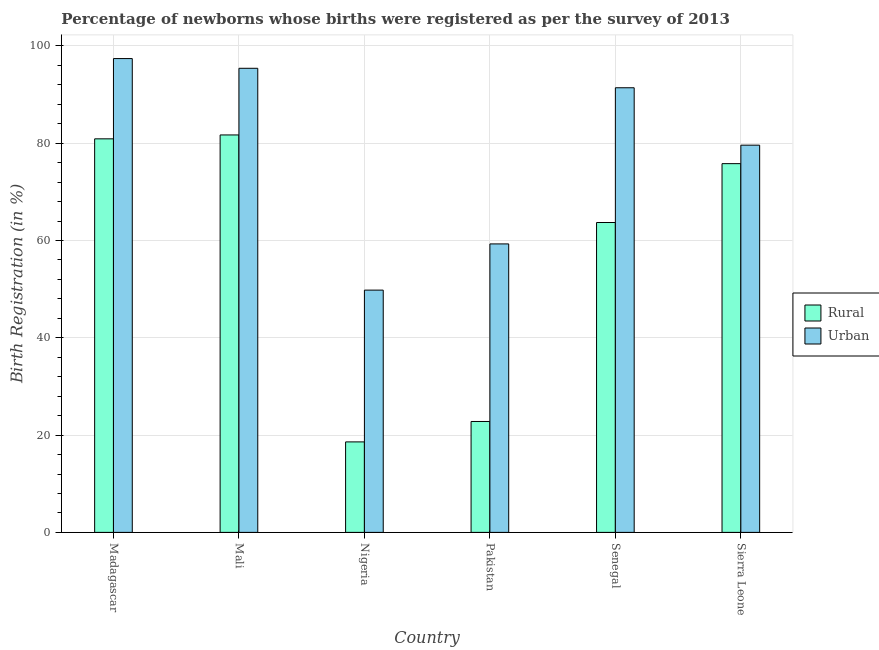How many groups of bars are there?
Your response must be concise. 6. Are the number of bars on each tick of the X-axis equal?
Your answer should be compact. Yes. How many bars are there on the 6th tick from the right?
Offer a terse response. 2. What is the label of the 6th group of bars from the left?
Provide a short and direct response. Sierra Leone. Across all countries, what is the maximum urban birth registration?
Your answer should be very brief. 97.4. Across all countries, what is the minimum rural birth registration?
Provide a short and direct response. 18.6. In which country was the rural birth registration maximum?
Make the answer very short. Mali. In which country was the rural birth registration minimum?
Your answer should be very brief. Nigeria. What is the total urban birth registration in the graph?
Your response must be concise. 472.9. What is the difference between the urban birth registration in Madagascar and that in Sierra Leone?
Offer a very short reply. 17.8. What is the average urban birth registration per country?
Provide a succinct answer. 78.82. What is the ratio of the urban birth registration in Senegal to that in Sierra Leone?
Your response must be concise. 1.15. What is the difference between the highest and the second highest rural birth registration?
Your response must be concise. 0.8. What is the difference between the highest and the lowest rural birth registration?
Make the answer very short. 63.1. Is the sum of the rural birth registration in Pakistan and Senegal greater than the maximum urban birth registration across all countries?
Your answer should be very brief. No. What does the 2nd bar from the left in Pakistan represents?
Offer a terse response. Urban. What does the 2nd bar from the right in Sierra Leone represents?
Provide a short and direct response. Rural. How many bars are there?
Your answer should be very brief. 12. Are the values on the major ticks of Y-axis written in scientific E-notation?
Offer a very short reply. No. Where does the legend appear in the graph?
Give a very brief answer. Center right. How many legend labels are there?
Keep it short and to the point. 2. What is the title of the graph?
Offer a terse response. Percentage of newborns whose births were registered as per the survey of 2013. Does "Gasoline" appear as one of the legend labels in the graph?
Make the answer very short. No. What is the label or title of the X-axis?
Offer a very short reply. Country. What is the label or title of the Y-axis?
Give a very brief answer. Birth Registration (in %). What is the Birth Registration (in %) in Rural in Madagascar?
Keep it short and to the point. 80.9. What is the Birth Registration (in %) in Urban in Madagascar?
Your response must be concise. 97.4. What is the Birth Registration (in %) in Rural in Mali?
Make the answer very short. 81.7. What is the Birth Registration (in %) in Urban in Mali?
Your answer should be compact. 95.4. What is the Birth Registration (in %) of Urban in Nigeria?
Your answer should be very brief. 49.8. What is the Birth Registration (in %) of Rural in Pakistan?
Your answer should be compact. 22.8. What is the Birth Registration (in %) in Urban in Pakistan?
Provide a short and direct response. 59.3. What is the Birth Registration (in %) in Rural in Senegal?
Ensure brevity in your answer.  63.7. What is the Birth Registration (in %) of Urban in Senegal?
Offer a very short reply. 91.4. What is the Birth Registration (in %) of Rural in Sierra Leone?
Your answer should be compact. 75.8. What is the Birth Registration (in %) of Urban in Sierra Leone?
Keep it short and to the point. 79.6. Across all countries, what is the maximum Birth Registration (in %) of Rural?
Give a very brief answer. 81.7. Across all countries, what is the maximum Birth Registration (in %) of Urban?
Provide a succinct answer. 97.4. Across all countries, what is the minimum Birth Registration (in %) of Urban?
Give a very brief answer. 49.8. What is the total Birth Registration (in %) in Rural in the graph?
Your answer should be compact. 343.5. What is the total Birth Registration (in %) in Urban in the graph?
Make the answer very short. 472.9. What is the difference between the Birth Registration (in %) in Urban in Madagascar and that in Mali?
Offer a very short reply. 2. What is the difference between the Birth Registration (in %) in Rural in Madagascar and that in Nigeria?
Your answer should be compact. 62.3. What is the difference between the Birth Registration (in %) in Urban in Madagascar and that in Nigeria?
Your answer should be very brief. 47.6. What is the difference between the Birth Registration (in %) in Rural in Madagascar and that in Pakistan?
Give a very brief answer. 58.1. What is the difference between the Birth Registration (in %) in Urban in Madagascar and that in Pakistan?
Your answer should be compact. 38.1. What is the difference between the Birth Registration (in %) of Rural in Madagascar and that in Senegal?
Provide a succinct answer. 17.2. What is the difference between the Birth Registration (in %) of Rural in Mali and that in Nigeria?
Make the answer very short. 63.1. What is the difference between the Birth Registration (in %) of Urban in Mali and that in Nigeria?
Your response must be concise. 45.6. What is the difference between the Birth Registration (in %) of Rural in Mali and that in Pakistan?
Keep it short and to the point. 58.9. What is the difference between the Birth Registration (in %) in Urban in Mali and that in Pakistan?
Provide a succinct answer. 36.1. What is the difference between the Birth Registration (in %) in Urban in Mali and that in Sierra Leone?
Offer a terse response. 15.8. What is the difference between the Birth Registration (in %) of Rural in Nigeria and that in Pakistan?
Make the answer very short. -4.2. What is the difference between the Birth Registration (in %) of Rural in Nigeria and that in Senegal?
Provide a succinct answer. -45.1. What is the difference between the Birth Registration (in %) in Urban in Nigeria and that in Senegal?
Make the answer very short. -41.6. What is the difference between the Birth Registration (in %) of Rural in Nigeria and that in Sierra Leone?
Your response must be concise. -57.2. What is the difference between the Birth Registration (in %) in Urban in Nigeria and that in Sierra Leone?
Your answer should be very brief. -29.8. What is the difference between the Birth Registration (in %) of Rural in Pakistan and that in Senegal?
Provide a succinct answer. -40.9. What is the difference between the Birth Registration (in %) of Urban in Pakistan and that in Senegal?
Your answer should be compact. -32.1. What is the difference between the Birth Registration (in %) in Rural in Pakistan and that in Sierra Leone?
Your response must be concise. -53. What is the difference between the Birth Registration (in %) in Urban in Pakistan and that in Sierra Leone?
Keep it short and to the point. -20.3. What is the difference between the Birth Registration (in %) of Rural in Madagascar and the Birth Registration (in %) of Urban in Nigeria?
Offer a very short reply. 31.1. What is the difference between the Birth Registration (in %) in Rural in Madagascar and the Birth Registration (in %) in Urban in Pakistan?
Your answer should be compact. 21.6. What is the difference between the Birth Registration (in %) of Rural in Mali and the Birth Registration (in %) of Urban in Nigeria?
Provide a succinct answer. 31.9. What is the difference between the Birth Registration (in %) of Rural in Mali and the Birth Registration (in %) of Urban in Pakistan?
Give a very brief answer. 22.4. What is the difference between the Birth Registration (in %) of Rural in Mali and the Birth Registration (in %) of Urban in Senegal?
Provide a succinct answer. -9.7. What is the difference between the Birth Registration (in %) of Rural in Nigeria and the Birth Registration (in %) of Urban in Pakistan?
Provide a short and direct response. -40.7. What is the difference between the Birth Registration (in %) in Rural in Nigeria and the Birth Registration (in %) in Urban in Senegal?
Your response must be concise. -72.8. What is the difference between the Birth Registration (in %) in Rural in Nigeria and the Birth Registration (in %) in Urban in Sierra Leone?
Ensure brevity in your answer.  -61. What is the difference between the Birth Registration (in %) of Rural in Pakistan and the Birth Registration (in %) of Urban in Senegal?
Ensure brevity in your answer.  -68.6. What is the difference between the Birth Registration (in %) of Rural in Pakistan and the Birth Registration (in %) of Urban in Sierra Leone?
Your answer should be compact. -56.8. What is the difference between the Birth Registration (in %) in Rural in Senegal and the Birth Registration (in %) in Urban in Sierra Leone?
Keep it short and to the point. -15.9. What is the average Birth Registration (in %) in Rural per country?
Your answer should be very brief. 57.25. What is the average Birth Registration (in %) of Urban per country?
Make the answer very short. 78.82. What is the difference between the Birth Registration (in %) in Rural and Birth Registration (in %) in Urban in Madagascar?
Make the answer very short. -16.5. What is the difference between the Birth Registration (in %) of Rural and Birth Registration (in %) of Urban in Mali?
Your response must be concise. -13.7. What is the difference between the Birth Registration (in %) in Rural and Birth Registration (in %) in Urban in Nigeria?
Your answer should be very brief. -31.2. What is the difference between the Birth Registration (in %) of Rural and Birth Registration (in %) of Urban in Pakistan?
Your answer should be compact. -36.5. What is the difference between the Birth Registration (in %) of Rural and Birth Registration (in %) of Urban in Senegal?
Offer a terse response. -27.7. What is the difference between the Birth Registration (in %) of Rural and Birth Registration (in %) of Urban in Sierra Leone?
Keep it short and to the point. -3.8. What is the ratio of the Birth Registration (in %) in Rural in Madagascar to that in Mali?
Your answer should be compact. 0.99. What is the ratio of the Birth Registration (in %) of Rural in Madagascar to that in Nigeria?
Your answer should be very brief. 4.35. What is the ratio of the Birth Registration (in %) of Urban in Madagascar to that in Nigeria?
Your response must be concise. 1.96. What is the ratio of the Birth Registration (in %) of Rural in Madagascar to that in Pakistan?
Provide a short and direct response. 3.55. What is the ratio of the Birth Registration (in %) of Urban in Madagascar to that in Pakistan?
Provide a short and direct response. 1.64. What is the ratio of the Birth Registration (in %) in Rural in Madagascar to that in Senegal?
Your answer should be compact. 1.27. What is the ratio of the Birth Registration (in %) in Urban in Madagascar to that in Senegal?
Offer a very short reply. 1.07. What is the ratio of the Birth Registration (in %) of Rural in Madagascar to that in Sierra Leone?
Your answer should be very brief. 1.07. What is the ratio of the Birth Registration (in %) in Urban in Madagascar to that in Sierra Leone?
Make the answer very short. 1.22. What is the ratio of the Birth Registration (in %) in Rural in Mali to that in Nigeria?
Offer a terse response. 4.39. What is the ratio of the Birth Registration (in %) of Urban in Mali to that in Nigeria?
Provide a succinct answer. 1.92. What is the ratio of the Birth Registration (in %) of Rural in Mali to that in Pakistan?
Make the answer very short. 3.58. What is the ratio of the Birth Registration (in %) in Urban in Mali to that in Pakistan?
Keep it short and to the point. 1.61. What is the ratio of the Birth Registration (in %) of Rural in Mali to that in Senegal?
Provide a succinct answer. 1.28. What is the ratio of the Birth Registration (in %) of Urban in Mali to that in Senegal?
Make the answer very short. 1.04. What is the ratio of the Birth Registration (in %) in Rural in Mali to that in Sierra Leone?
Give a very brief answer. 1.08. What is the ratio of the Birth Registration (in %) of Urban in Mali to that in Sierra Leone?
Your response must be concise. 1.2. What is the ratio of the Birth Registration (in %) of Rural in Nigeria to that in Pakistan?
Your response must be concise. 0.82. What is the ratio of the Birth Registration (in %) in Urban in Nigeria to that in Pakistan?
Give a very brief answer. 0.84. What is the ratio of the Birth Registration (in %) of Rural in Nigeria to that in Senegal?
Give a very brief answer. 0.29. What is the ratio of the Birth Registration (in %) of Urban in Nigeria to that in Senegal?
Your answer should be very brief. 0.54. What is the ratio of the Birth Registration (in %) of Rural in Nigeria to that in Sierra Leone?
Ensure brevity in your answer.  0.25. What is the ratio of the Birth Registration (in %) of Urban in Nigeria to that in Sierra Leone?
Make the answer very short. 0.63. What is the ratio of the Birth Registration (in %) in Rural in Pakistan to that in Senegal?
Give a very brief answer. 0.36. What is the ratio of the Birth Registration (in %) in Urban in Pakistan to that in Senegal?
Provide a short and direct response. 0.65. What is the ratio of the Birth Registration (in %) of Rural in Pakistan to that in Sierra Leone?
Make the answer very short. 0.3. What is the ratio of the Birth Registration (in %) in Urban in Pakistan to that in Sierra Leone?
Offer a terse response. 0.74. What is the ratio of the Birth Registration (in %) of Rural in Senegal to that in Sierra Leone?
Offer a terse response. 0.84. What is the ratio of the Birth Registration (in %) in Urban in Senegal to that in Sierra Leone?
Offer a terse response. 1.15. What is the difference between the highest and the second highest Birth Registration (in %) of Urban?
Your answer should be compact. 2. What is the difference between the highest and the lowest Birth Registration (in %) of Rural?
Offer a very short reply. 63.1. What is the difference between the highest and the lowest Birth Registration (in %) of Urban?
Your answer should be compact. 47.6. 